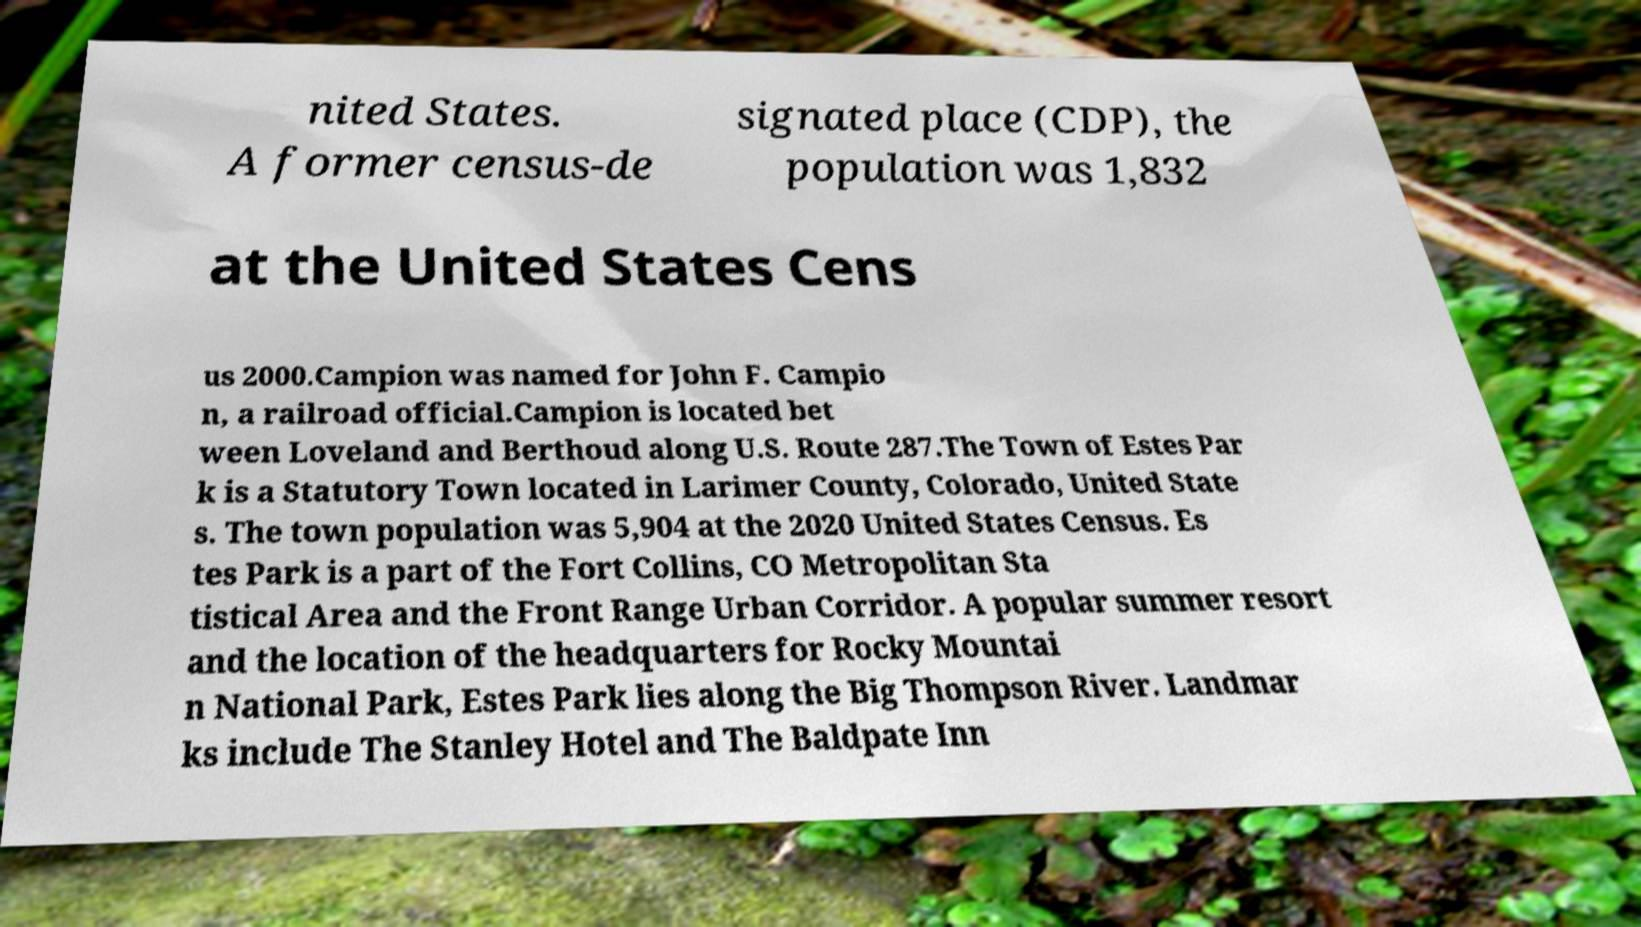There's text embedded in this image that I need extracted. Can you transcribe it verbatim? nited States. A former census-de signated place (CDP), the population was 1,832 at the United States Cens us 2000.Campion was named for John F. Campio n, a railroad official.Campion is located bet ween Loveland and Berthoud along U.S. Route 287.The Town of Estes Par k is a Statutory Town located in Larimer County, Colorado, United State s. The town population was 5,904 at the 2020 United States Census. Es tes Park is a part of the Fort Collins, CO Metropolitan Sta tistical Area and the Front Range Urban Corridor. A popular summer resort and the location of the headquarters for Rocky Mountai n National Park, Estes Park lies along the Big Thompson River. Landmar ks include The Stanley Hotel and The Baldpate Inn 